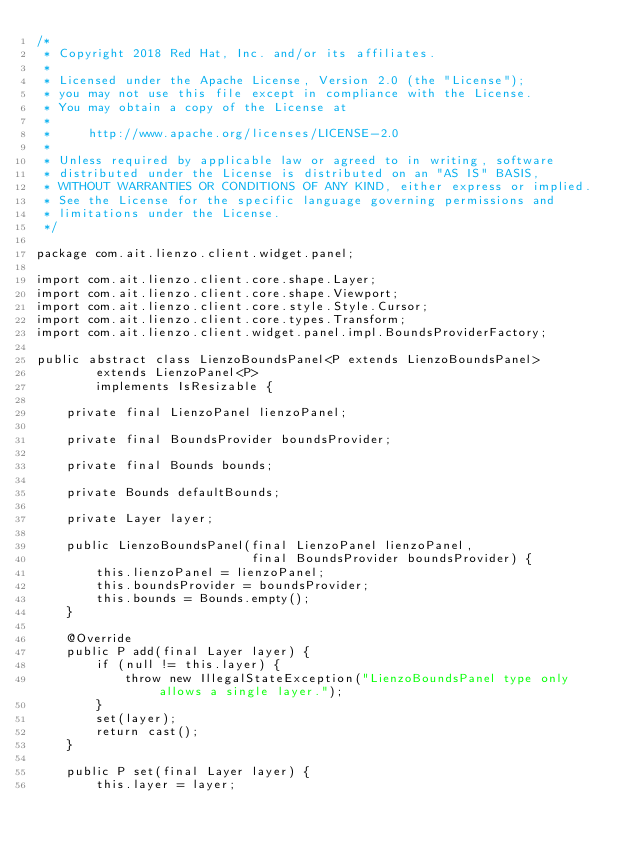Convert code to text. <code><loc_0><loc_0><loc_500><loc_500><_Java_>/*
 * Copyright 2018 Red Hat, Inc. and/or its affiliates.
 *
 * Licensed under the Apache License, Version 2.0 (the "License");
 * you may not use this file except in compliance with the License.
 * You may obtain a copy of the License at
 *
 *     http://www.apache.org/licenses/LICENSE-2.0
 *
 * Unless required by applicable law or agreed to in writing, software
 * distributed under the License is distributed on an "AS IS" BASIS,
 * WITHOUT WARRANTIES OR CONDITIONS OF ANY KIND, either express or implied.
 * See the License for the specific language governing permissions and
 * limitations under the License.
 */

package com.ait.lienzo.client.widget.panel;

import com.ait.lienzo.client.core.shape.Layer;
import com.ait.lienzo.client.core.shape.Viewport;
import com.ait.lienzo.client.core.style.Style.Cursor;
import com.ait.lienzo.client.core.types.Transform;
import com.ait.lienzo.client.widget.panel.impl.BoundsProviderFactory;

public abstract class LienzoBoundsPanel<P extends LienzoBoundsPanel>
        extends LienzoPanel<P>
        implements IsResizable {

    private final LienzoPanel lienzoPanel;

    private final BoundsProvider boundsProvider;

    private final Bounds bounds;

    private Bounds defaultBounds;

    private Layer layer;

    public LienzoBoundsPanel(final LienzoPanel lienzoPanel,
                             final BoundsProvider boundsProvider) {
        this.lienzoPanel = lienzoPanel;
        this.boundsProvider = boundsProvider;
        this.bounds = Bounds.empty();
    }

    @Override
    public P add(final Layer layer) {
        if (null != this.layer) {
            throw new IllegalStateException("LienzoBoundsPanel type only allows a single layer.");
        }
        set(layer);
        return cast();
    }

    public P set(final Layer layer) {
        this.layer = layer;</code> 